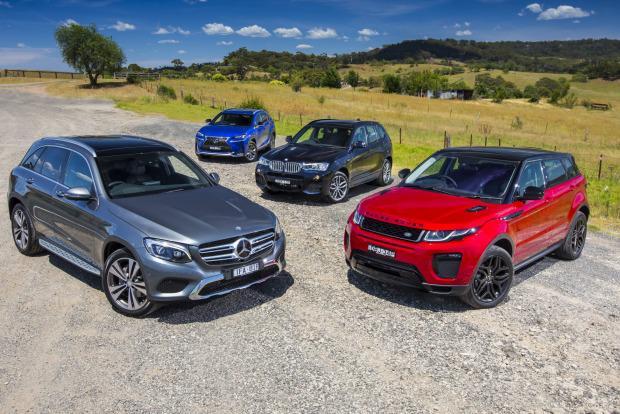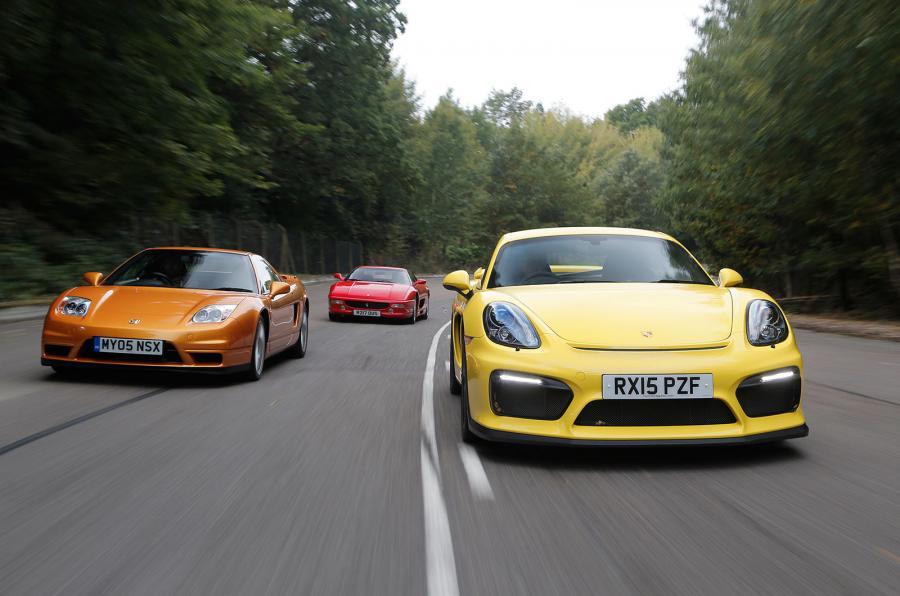The first image is the image on the left, the second image is the image on the right. Considering the images on both sides, is "There are two cars being driven on roads." valid? Answer yes or no. No. The first image is the image on the left, the second image is the image on the right. For the images shown, is this caption "The left image contains two cars including one blue one, and the right image includes a dark red convertible with its top down." true? Answer yes or no. No. 